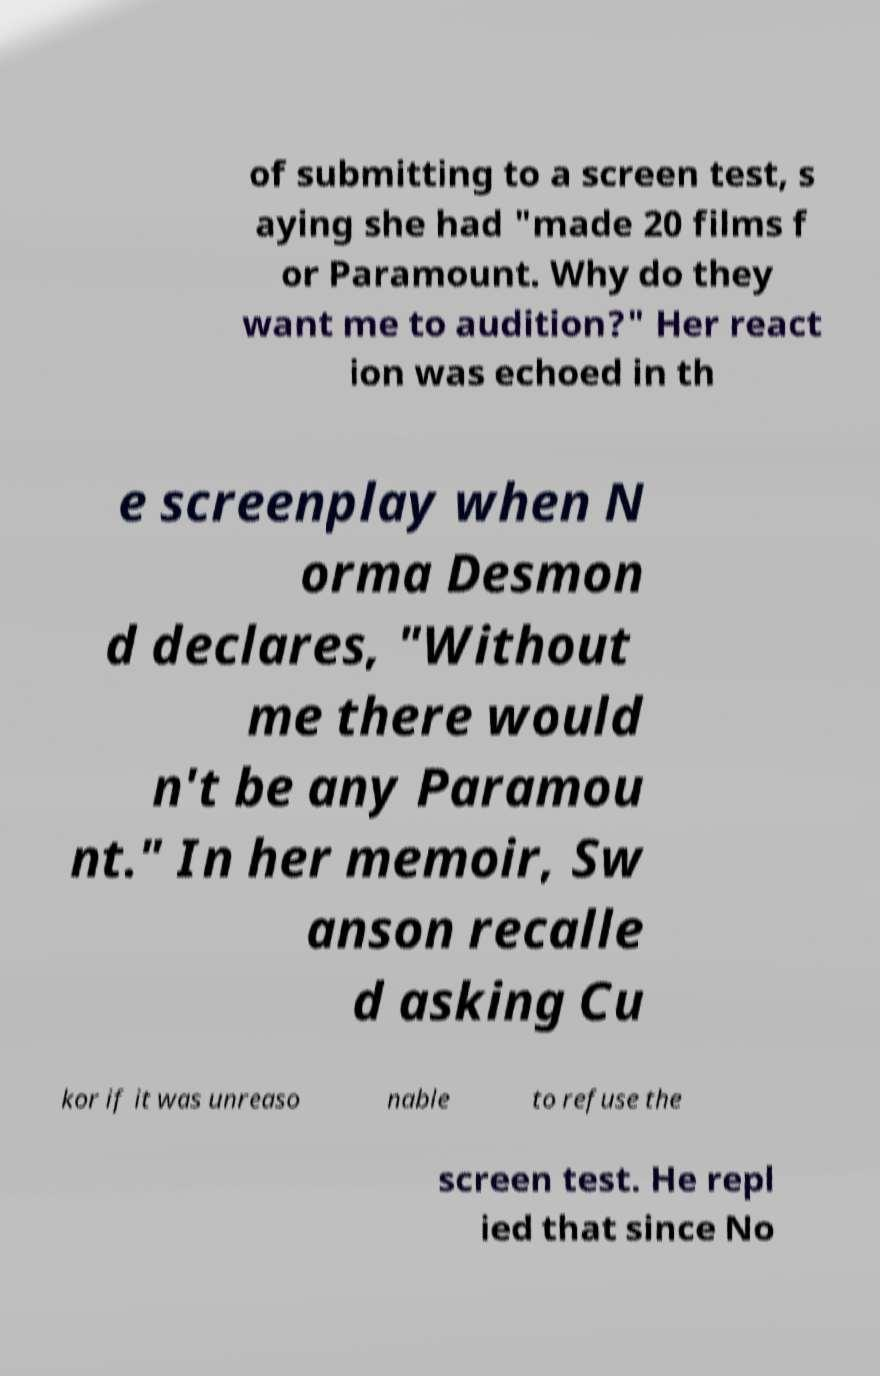Please read and relay the text visible in this image. What does it say? of submitting to a screen test, s aying she had "made 20 films f or Paramount. Why do they want me to audition?" Her react ion was echoed in th e screenplay when N orma Desmon d declares, "Without me there would n't be any Paramou nt." In her memoir, Sw anson recalle d asking Cu kor if it was unreaso nable to refuse the screen test. He repl ied that since No 